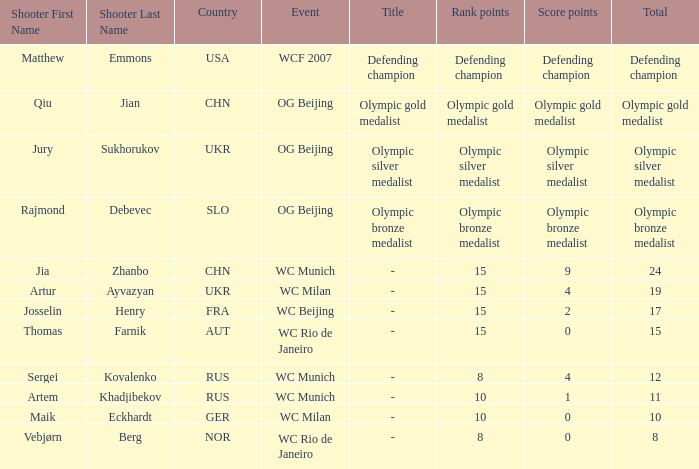Who was the shooter for the WC Beijing event? Josselin Henry ( FRA ). 